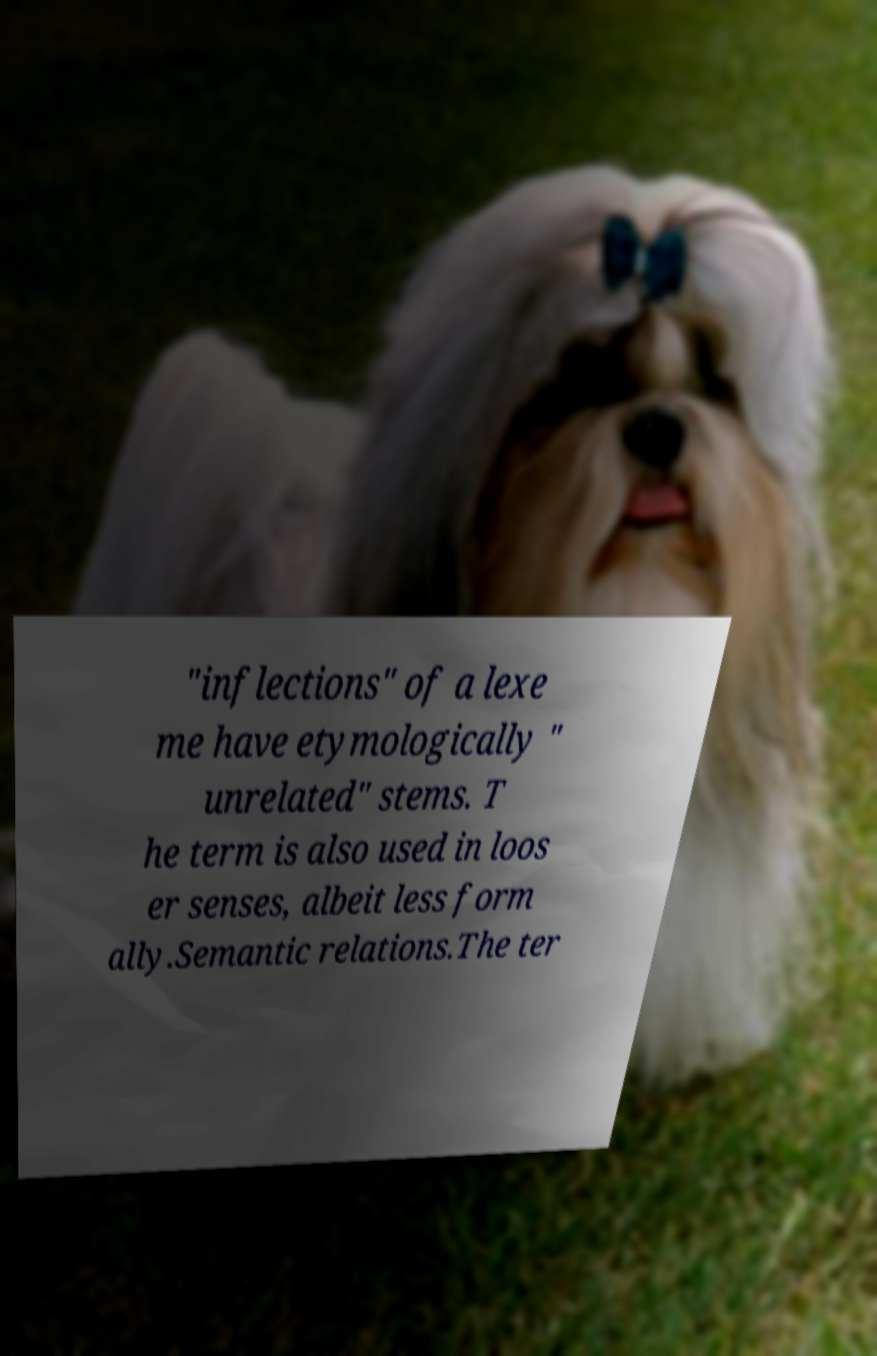Please read and relay the text visible in this image. What does it say? "inflections" of a lexe me have etymologically " unrelated" stems. T he term is also used in loos er senses, albeit less form ally.Semantic relations.The ter 